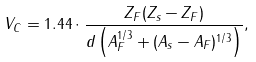<formula> <loc_0><loc_0><loc_500><loc_500>V _ { C } = 1 . 4 4 \cdot \frac { Z _ { F } ( Z _ { s } - Z _ { F } ) } { d \left ( A _ { F } ^ { 1 / 3 } + ( A _ { s } - A _ { F } ) ^ { 1 / 3 } \right ) } ,</formula> 